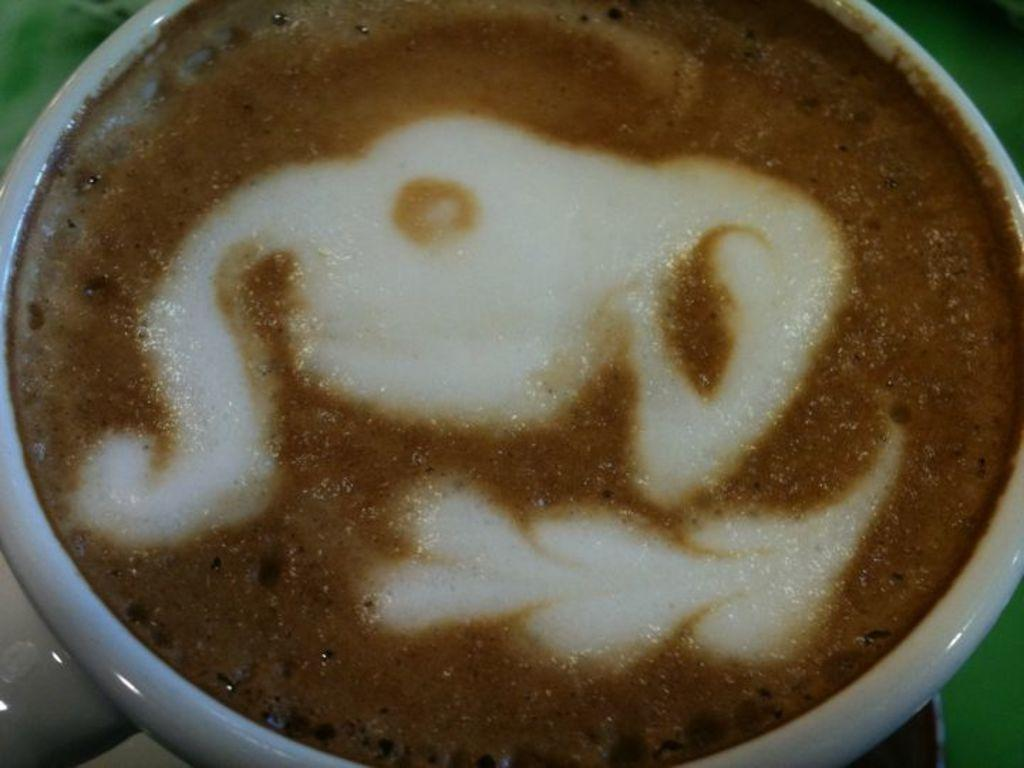What is in the image? There is a cup in the image. What is inside the cup? The cup contains coffee. How many legs are visible in the image? There are no legs visible in the image; it only contains a cup with coffee. 